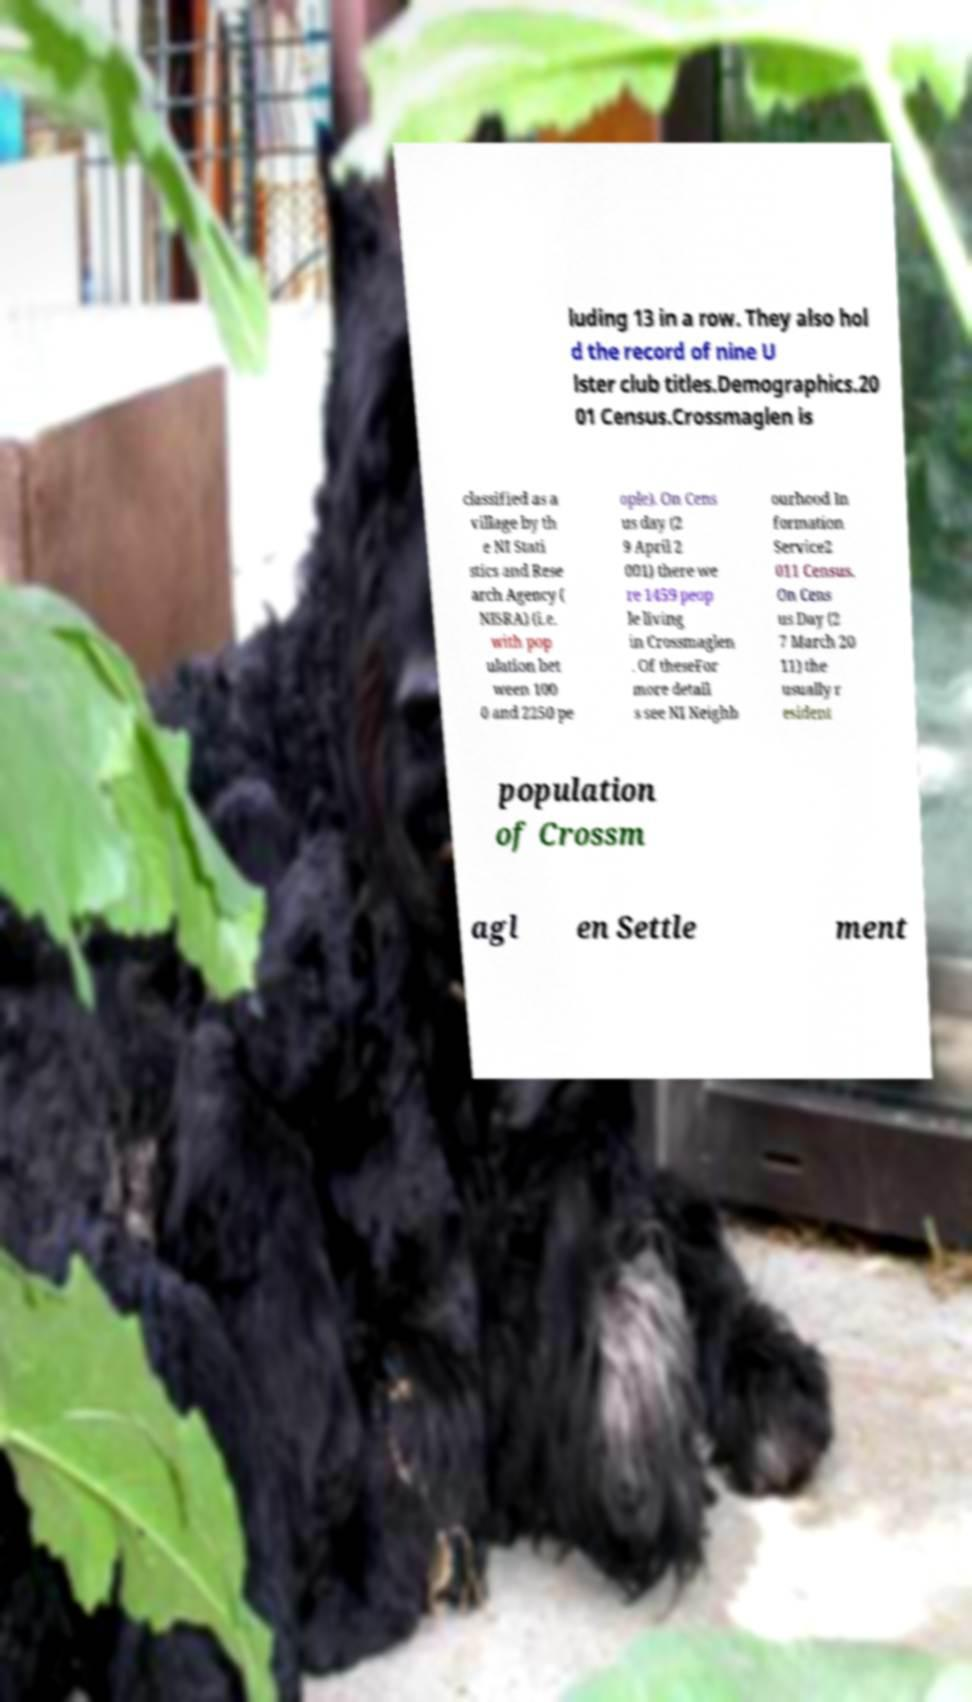Please read and relay the text visible in this image. What does it say? luding 13 in a row. They also hol d the record of nine U lster club titles.Demographics.20 01 Census.Crossmaglen is classified as a village by th e NI Stati stics and Rese arch Agency ( NISRA) (i.e. with pop ulation bet ween 100 0 and 2250 pe ople). On Cens us day (2 9 April 2 001) there we re 1459 peop le living in Crossmaglen . Of theseFor more detail s see NI Neighb ourhood In formation Service2 011 Census. On Cens us Day (2 7 March 20 11) the usually r esident population of Crossm agl en Settle ment 